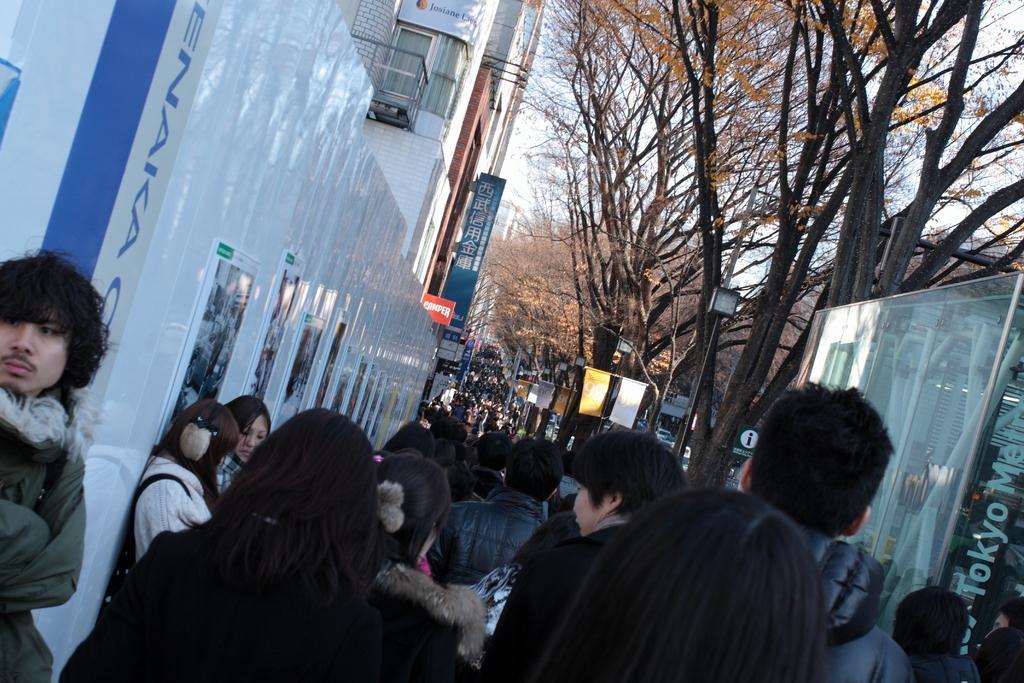Describe this image in one or two sentences. At the bottom of the image a group of people are there. In the background of the image we can see buildings, windows, boards, electric light poles, trees. At the top of the image there is a sky. 